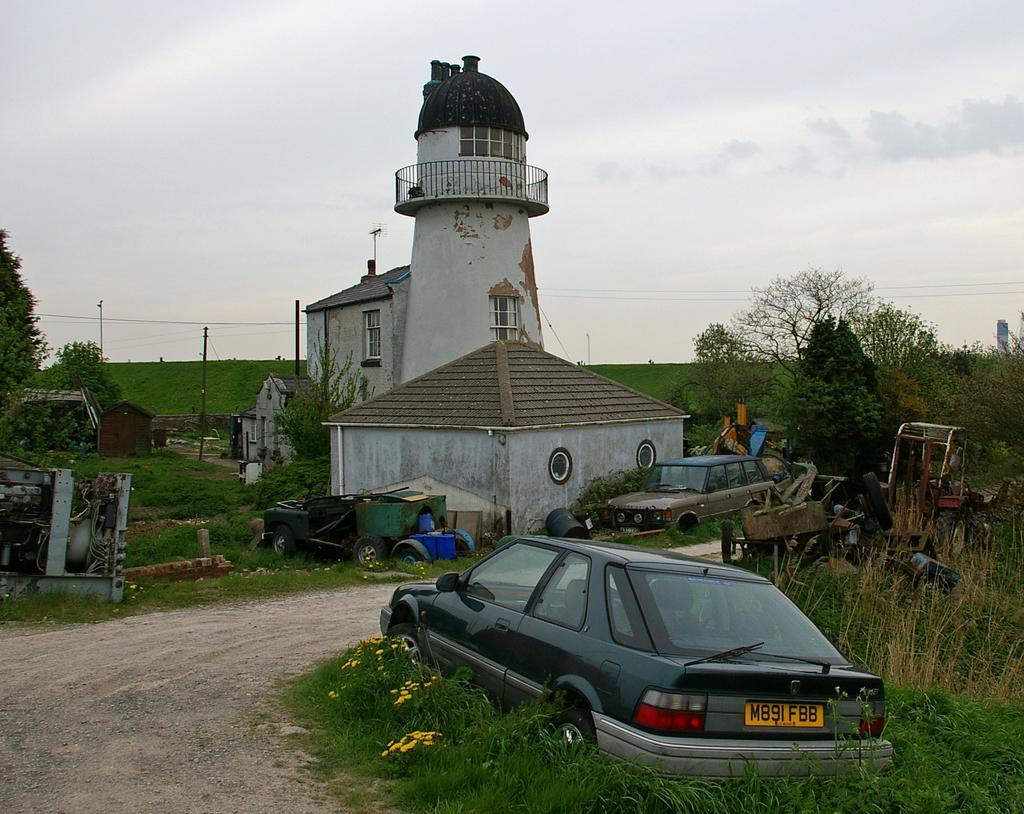In one or two sentences, can you explain what this image depicts? This picture is clicked outside. On the right there is a car and we can see the flowers and the green grass. In the background there is a sky, tower, hut and some other objects placed on the ground and we can see the poles, green grass, trees and plants. 